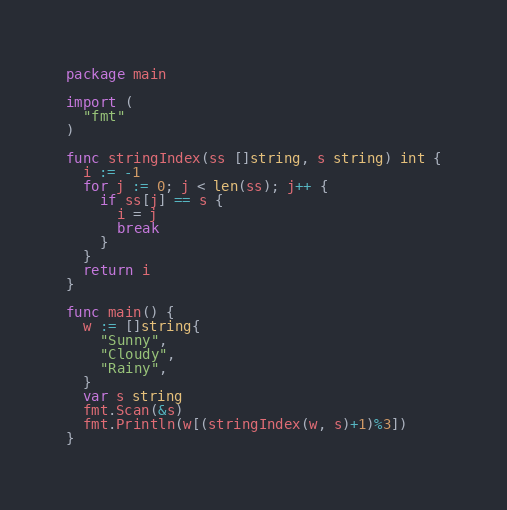<code> <loc_0><loc_0><loc_500><loc_500><_Go_>package main

import (
  "fmt"
)

func stringIndex(ss []string, s string) int {
  i := -1
  for j := 0; j < len(ss); j++ {
    if ss[j] == s {
      i = j 
      break
    }
  }
  return i
}

func main() {
  w := []string{
    "Sunny",
    "Cloudy",
    "Rainy",
  }
  var s string
  fmt.Scan(&s)
  fmt.Println(w[(stringIndex(w, s)+1)%3])
}</code> 